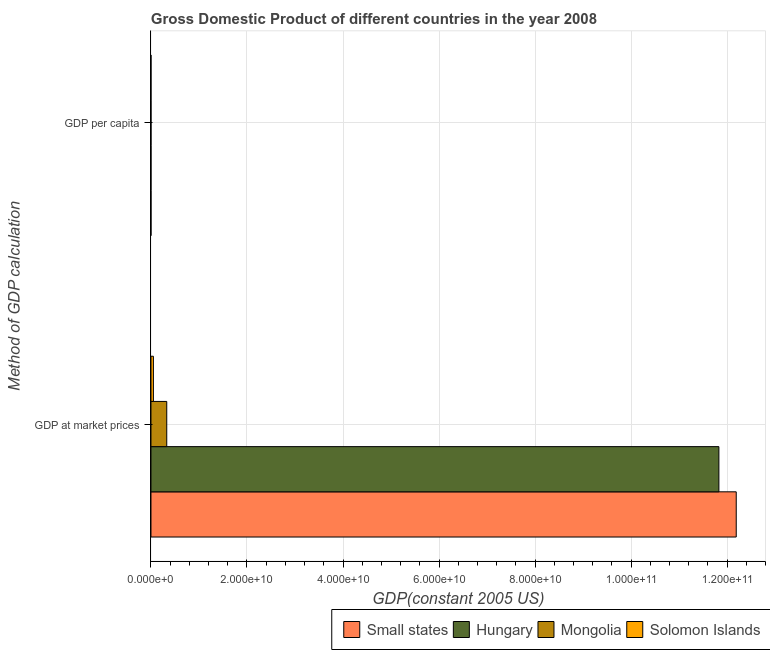Are the number of bars on each tick of the Y-axis equal?
Offer a very short reply. Yes. How many bars are there on the 2nd tick from the top?
Make the answer very short. 4. How many bars are there on the 1st tick from the bottom?
Your response must be concise. 4. What is the label of the 2nd group of bars from the top?
Ensure brevity in your answer.  GDP at market prices. What is the gdp at market prices in Solomon Islands?
Make the answer very short. 5.09e+08. Across all countries, what is the maximum gdp at market prices?
Make the answer very short. 1.22e+11. Across all countries, what is the minimum gdp per capita?
Make the answer very short. 1010.65. In which country was the gdp at market prices maximum?
Your answer should be compact. Small states. In which country was the gdp per capita minimum?
Your answer should be very brief. Solomon Islands. What is the total gdp per capita in the graph?
Your response must be concise. 1.85e+04. What is the difference between the gdp at market prices in Solomon Islands and that in Hungary?
Provide a short and direct response. -1.18e+11. What is the difference between the gdp per capita in Small states and the gdp at market prices in Hungary?
Offer a very short reply. -1.18e+11. What is the average gdp per capita per country?
Your response must be concise. 4616.28. What is the difference between the gdp per capita and gdp at market prices in Small states?
Offer a terse response. -1.22e+11. What is the ratio of the gdp at market prices in Small states to that in Mongolia?
Keep it short and to the point. 37.07. Is the gdp at market prices in Solomon Islands less than that in Mongolia?
Provide a succinct answer. Yes. In how many countries, is the gdp per capita greater than the average gdp per capita taken over all countries?
Provide a short and direct response. 1. What does the 1st bar from the top in GDP at market prices represents?
Keep it short and to the point. Solomon Islands. What does the 3rd bar from the bottom in GDP per capita represents?
Ensure brevity in your answer.  Mongolia. How many bars are there?
Ensure brevity in your answer.  8. Are all the bars in the graph horizontal?
Your response must be concise. Yes. How many countries are there in the graph?
Provide a succinct answer. 4. Are the values on the major ticks of X-axis written in scientific E-notation?
Provide a succinct answer. Yes. Does the graph contain grids?
Make the answer very short. Yes. Where does the legend appear in the graph?
Make the answer very short. Bottom right. How many legend labels are there?
Provide a succinct answer. 4. What is the title of the graph?
Your answer should be compact. Gross Domestic Product of different countries in the year 2008. Does "South Africa" appear as one of the legend labels in the graph?
Keep it short and to the point. No. What is the label or title of the X-axis?
Your answer should be compact. GDP(constant 2005 US). What is the label or title of the Y-axis?
Your response must be concise. Method of GDP calculation. What is the GDP(constant 2005 US) of Small states in GDP at market prices?
Provide a succinct answer. 1.22e+11. What is the GDP(constant 2005 US) in Hungary in GDP at market prices?
Give a very brief answer. 1.18e+11. What is the GDP(constant 2005 US) in Mongolia in GDP at market prices?
Provide a short and direct response. 3.29e+09. What is the GDP(constant 2005 US) in Solomon Islands in GDP at market prices?
Ensure brevity in your answer.  5.09e+08. What is the GDP(constant 2005 US) of Small states in GDP per capita?
Provide a short and direct response. 4419.14. What is the GDP(constant 2005 US) in Hungary in GDP per capita?
Provide a short and direct response. 1.18e+04. What is the GDP(constant 2005 US) of Mongolia in GDP per capita?
Provide a short and direct response. 1250.7. What is the GDP(constant 2005 US) in Solomon Islands in GDP per capita?
Your answer should be compact. 1010.65. Across all Method of GDP calculation, what is the maximum GDP(constant 2005 US) in Small states?
Ensure brevity in your answer.  1.22e+11. Across all Method of GDP calculation, what is the maximum GDP(constant 2005 US) of Hungary?
Provide a succinct answer. 1.18e+11. Across all Method of GDP calculation, what is the maximum GDP(constant 2005 US) in Mongolia?
Ensure brevity in your answer.  3.29e+09. Across all Method of GDP calculation, what is the maximum GDP(constant 2005 US) in Solomon Islands?
Provide a short and direct response. 5.09e+08. Across all Method of GDP calculation, what is the minimum GDP(constant 2005 US) in Small states?
Offer a very short reply. 4419.14. Across all Method of GDP calculation, what is the minimum GDP(constant 2005 US) of Hungary?
Give a very brief answer. 1.18e+04. Across all Method of GDP calculation, what is the minimum GDP(constant 2005 US) of Mongolia?
Give a very brief answer. 1250.7. Across all Method of GDP calculation, what is the minimum GDP(constant 2005 US) in Solomon Islands?
Give a very brief answer. 1010.65. What is the total GDP(constant 2005 US) of Small states in the graph?
Provide a succinct answer. 1.22e+11. What is the total GDP(constant 2005 US) of Hungary in the graph?
Give a very brief answer. 1.18e+11. What is the total GDP(constant 2005 US) of Mongolia in the graph?
Keep it short and to the point. 3.29e+09. What is the total GDP(constant 2005 US) of Solomon Islands in the graph?
Give a very brief answer. 5.09e+08. What is the difference between the GDP(constant 2005 US) in Small states in GDP at market prices and that in GDP per capita?
Your response must be concise. 1.22e+11. What is the difference between the GDP(constant 2005 US) in Hungary in GDP at market prices and that in GDP per capita?
Make the answer very short. 1.18e+11. What is the difference between the GDP(constant 2005 US) of Mongolia in GDP at market prices and that in GDP per capita?
Your answer should be very brief. 3.29e+09. What is the difference between the GDP(constant 2005 US) of Solomon Islands in GDP at market prices and that in GDP per capita?
Your response must be concise. 5.09e+08. What is the difference between the GDP(constant 2005 US) in Small states in GDP at market prices and the GDP(constant 2005 US) in Hungary in GDP per capita?
Provide a short and direct response. 1.22e+11. What is the difference between the GDP(constant 2005 US) in Small states in GDP at market prices and the GDP(constant 2005 US) in Mongolia in GDP per capita?
Offer a terse response. 1.22e+11. What is the difference between the GDP(constant 2005 US) of Small states in GDP at market prices and the GDP(constant 2005 US) of Solomon Islands in GDP per capita?
Your answer should be very brief. 1.22e+11. What is the difference between the GDP(constant 2005 US) in Hungary in GDP at market prices and the GDP(constant 2005 US) in Mongolia in GDP per capita?
Make the answer very short. 1.18e+11. What is the difference between the GDP(constant 2005 US) in Hungary in GDP at market prices and the GDP(constant 2005 US) in Solomon Islands in GDP per capita?
Provide a succinct answer. 1.18e+11. What is the difference between the GDP(constant 2005 US) of Mongolia in GDP at market prices and the GDP(constant 2005 US) of Solomon Islands in GDP per capita?
Make the answer very short. 3.29e+09. What is the average GDP(constant 2005 US) in Small states per Method of GDP calculation?
Your answer should be very brief. 6.10e+1. What is the average GDP(constant 2005 US) in Hungary per Method of GDP calculation?
Offer a terse response. 5.91e+1. What is the average GDP(constant 2005 US) in Mongolia per Method of GDP calculation?
Provide a succinct answer. 1.64e+09. What is the average GDP(constant 2005 US) in Solomon Islands per Method of GDP calculation?
Offer a terse response. 2.54e+08. What is the difference between the GDP(constant 2005 US) in Small states and GDP(constant 2005 US) in Hungary in GDP at market prices?
Make the answer very short. 3.61e+09. What is the difference between the GDP(constant 2005 US) in Small states and GDP(constant 2005 US) in Mongolia in GDP at market prices?
Your answer should be very brief. 1.19e+11. What is the difference between the GDP(constant 2005 US) in Small states and GDP(constant 2005 US) in Solomon Islands in GDP at market prices?
Your response must be concise. 1.21e+11. What is the difference between the GDP(constant 2005 US) of Hungary and GDP(constant 2005 US) of Mongolia in GDP at market prices?
Make the answer very short. 1.15e+11. What is the difference between the GDP(constant 2005 US) in Hungary and GDP(constant 2005 US) in Solomon Islands in GDP at market prices?
Provide a short and direct response. 1.18e+11. What is the difference between the GDP(constant 2005 US) in Mongolia and GDP(constant 2005 US) in Solomon Islands in GDP at market prices?
Give a very brief answer. 2.78e+09. What is the difference between the GDP(constant 2005 US) in Small states and GDP(constant 2005 US) in Hungary in GDP per capita?
Offer a terse response. -7365.49. What is the difference between the GDP(constant 2005 US) of Small states and GDP(constant 2005 US) of Mongolia in GDP per capita?
Keep it short and to the point. 3168.44. What is the difference between the GDP(constant 2005 US) in Small states and GDP(constant 2005 US) in Solomon Islands in GDP per capita?
Provide a succinct answer. 3408.49. What is the difference between the GDP(constant 2005 US) in Hungary and GDP(constant 2005 US) in Mongolia in GDP per capita?
Provide a succinct answer. 1.05e+04. What is the difference between the GDP(constant 2005 US) of Hungary and GDP(constant 2005 US) of Solomon Islands in GDP per capita?
Make the answer very short. 1.08e+04. What is the difference between the GDP(constant 2005 US) of Mongolia and GDP(constant 2005 US) of Solomon Islands in GDP per capita?
Your response must be concise. 240.05. What is the ratio of the GDP(constant 2005 US) in Small states in GDP at market prices to that in GDP per capita?
Give a very brief answer. 2.76e+07. What is the ratio of the GDP(constant 2005 US) of Hungary in GDP at market prices to that in GDP per capita?
Provide a succinct answer. 1.00e+07. What is the ratio of the GDP(constant 2005 US) in Mongolia in GDP at market prices to that in GDP per capita?
Provide a succinct answer. 2.63e+06. What is the ratio of the GDP(constant 2005 US) of Solomon Islands in GDP at market prices to that in GDP per capita?
Ensure brevity in your answer.  5.03e+05. What is the difference between the highest and the second highest GDP(constant 2005 US) of Small states?
Ensure brevity in your answer.  1.22e+11. What is the difference between the highest and the second highest GDP(constant 2005 US) in Hungary?
Ensure brevity in your answer.  1.18e+11. What is the difference between the highest and the second highest GDP(constant 2005 US) in Mongolia?
Your answer should be compact. 3.29e+09. What is the difference between the highest and the second highest GDP(constant 2005 US) of Solomon Islands?
Offer a very short reply. 5.09e+08. What is the difference between the highest and the lowest GDP(constant 2005 US) in Small states?
Your response must be concise. 1.22e+11. What is the difference between the highest and the lowest GDP(constant 2005 US) of Hungary?
Your answer should be very brief. 1.18e+11. What is the difference between the highest and the lowest GDP(constant 2005 US) of Mongolia?
Your response must be concise. 3.29e+09. What is the difference between the highest and the lowest GDP(constant 2005 US) of Solomon Islands?
Make the answer very short. 5.09e+08. 